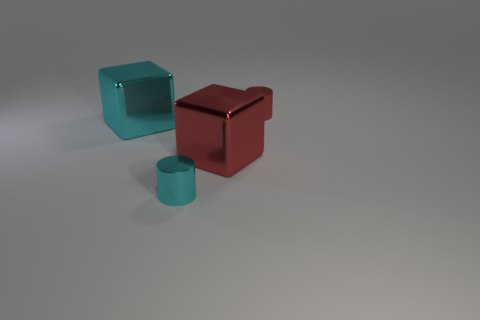There is a thing that is both right of the tiny cyan cylinder and in front of the large cyan shiny thing; what size is it?
Your answer should be compact. Large. What shape is the large cyan metal thing?
Offer a very short reply. Cube. Is there a shiny cylinder that is behind the tiny cyan thing that is in front of the cyan block?
Your answer should be compact. Yes. There is another block that is the same size as the cyan block; what material is it?
Make the answer very short. Metal. Is there a cyan metallic object of the same size as the cyan metallic cube?
Provide a short and direct response. No. There is a cylinder that is left of the big red cube; what is its material?
Your answer should be compact. Metal. Is the material of the large cyan object behind the small cyan cylinder the same as the small red cylinder?
Offer a very short reply. Yes. What is the shape of the object that is the same size as the cyan block?
Provide a succinct answer. Cube. Are there fewer red things that are in front of the tiny red object than small cyan metallic cylinders in front of the red cube?
Give a very brief answer. No. Are there any small objects in front of the large cyan metal object?
Make the answer very short. Yes. 